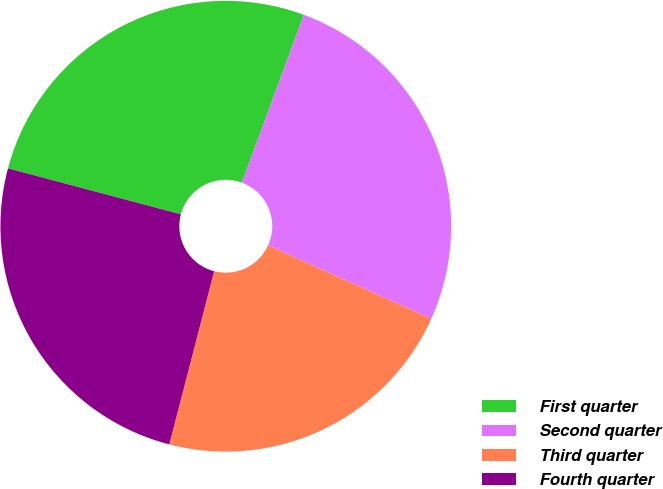Convert chart to OTSL. <chart><loc_0><loc_0><loc_500><loc_500><pie_chart><fcel>First quarter<fcel>Second quarter<fcel>Third quarter<fcel>Fourth quarter<nl><fcel>26.5%<fcel>26.1%<fcel>22.3%<fcel>25.1%<nl></chart> 